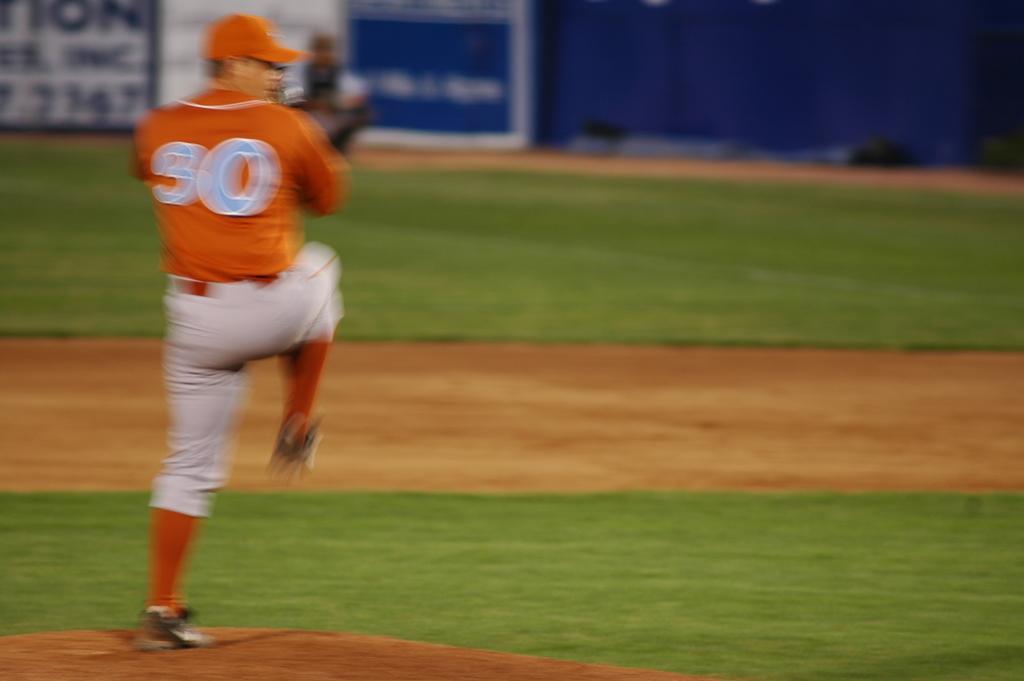In one or two sentences, can you explain what this image depicts? In this image I can see grass ground and on it I can see a man is standing. I can see he is wearing orange t shirt, white pant, shoes and orange cap. I can also see few numbers are written on his dress. In the background I can see few boards and on these words I can see something is written. I can also see this image is little bit blurry. 